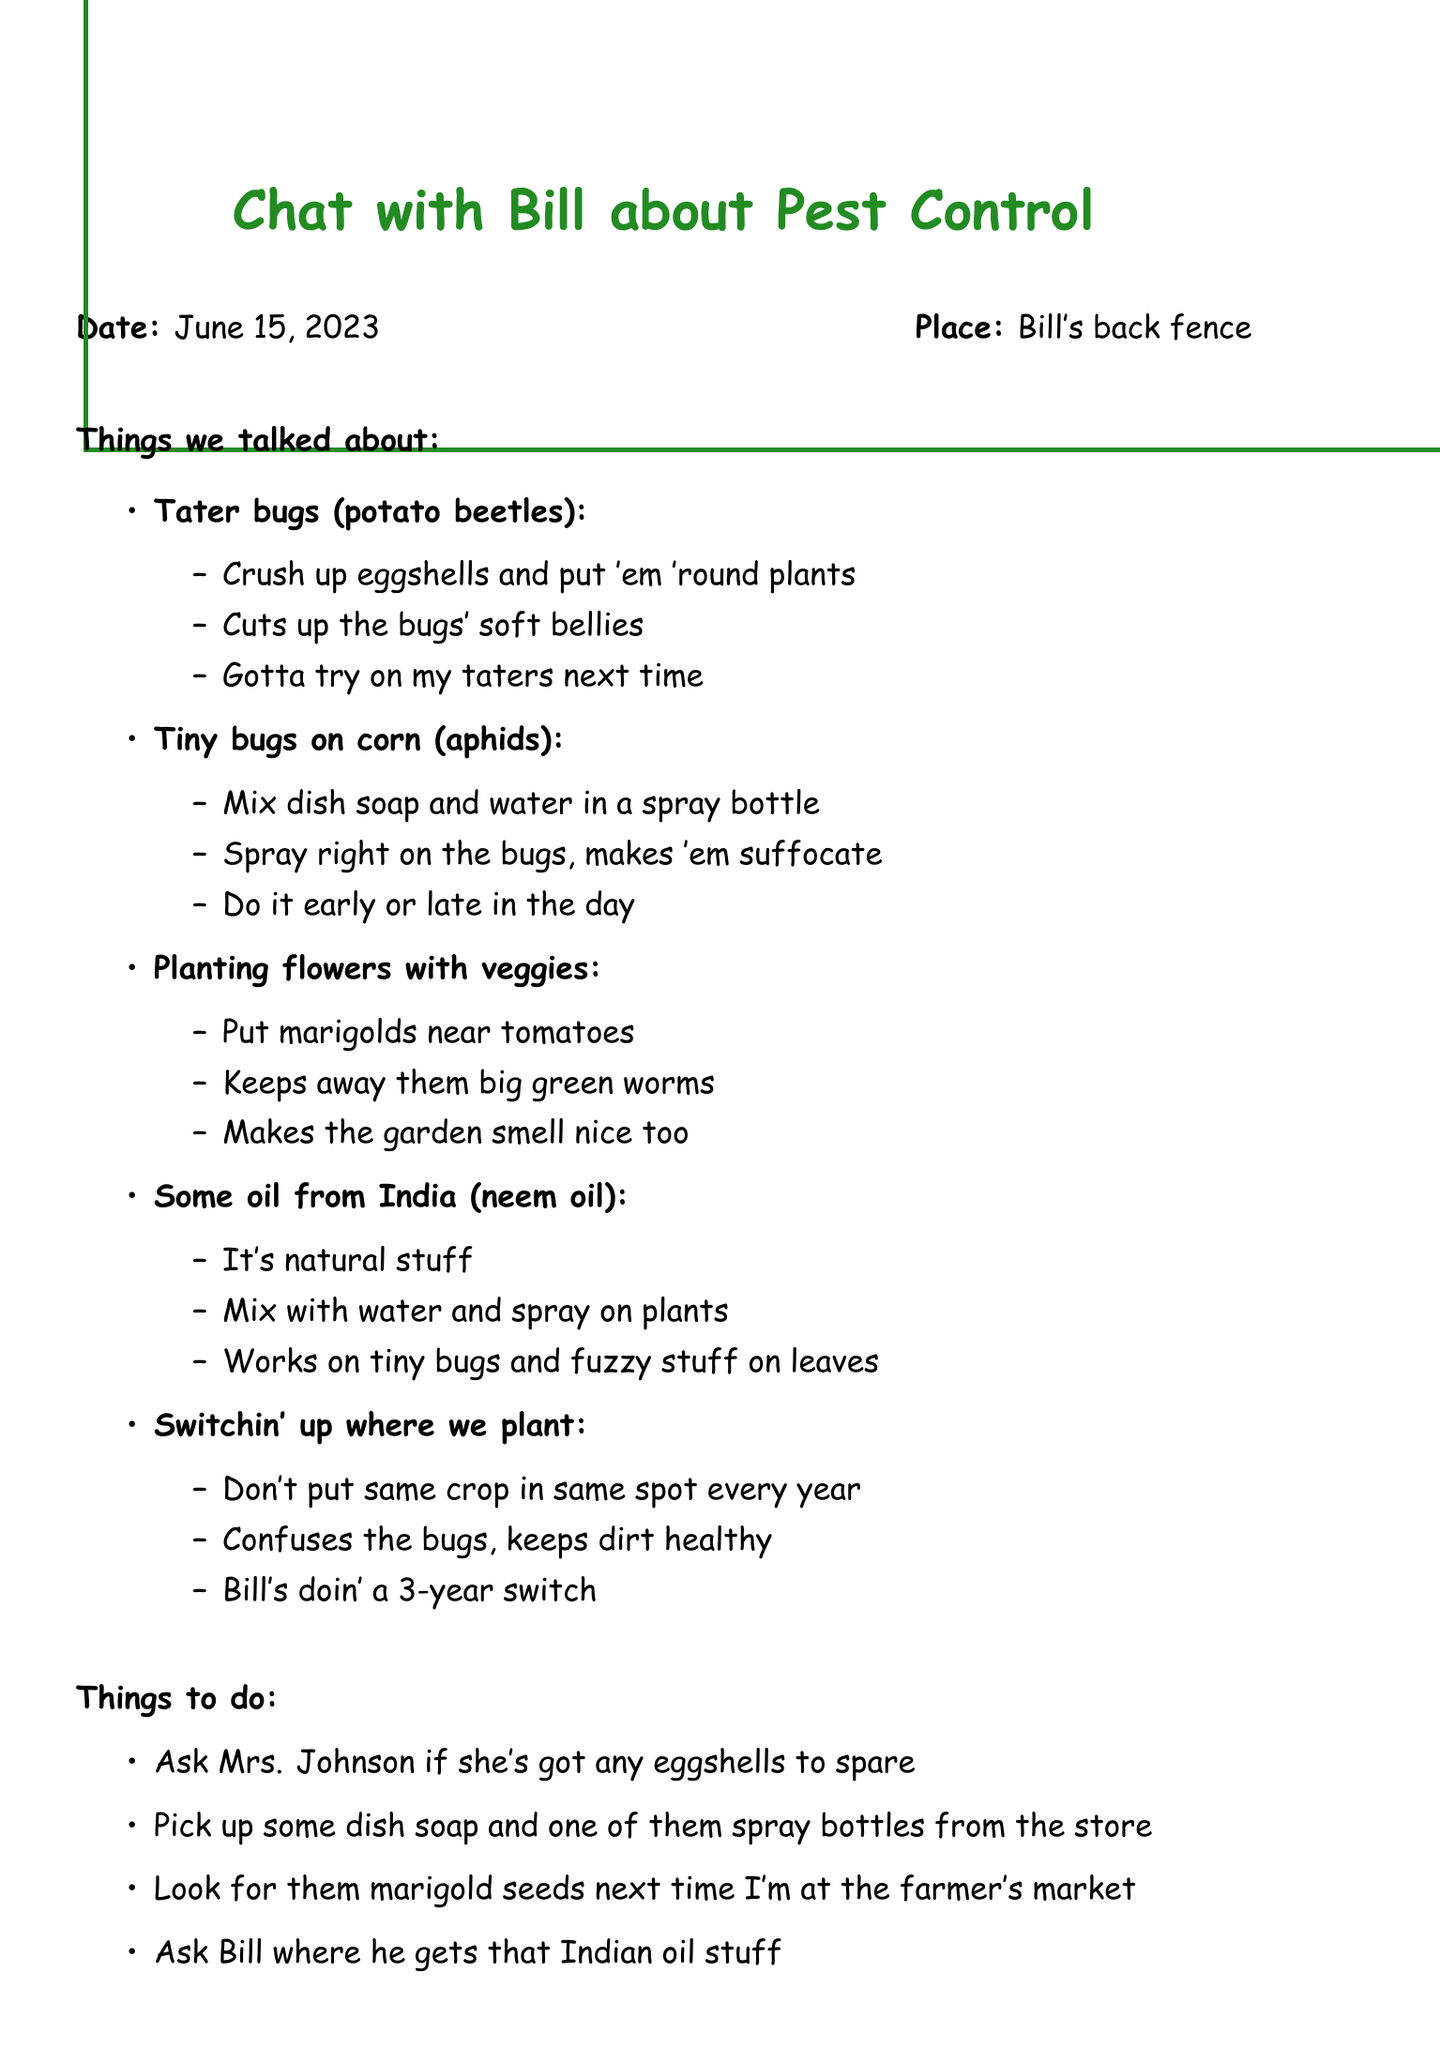What is the date of the conversation? The date of the conversation is stated at the beginning of the document.
Answer: June 15, 2023 Where did the conversation take place? The place of the conversation is mentioned alongside the date.
Answer: Bill's back fence What natural substance does Bill use to fight potato beetles? The document lists the method Bill uses for potato beetles in the notes section.
Answer: Crushed eggshells What is mixed with water to spray on aphids? The notes explain the method for dealing with aphids, including what to mix with water.
Answer: Dish soap How often does Bill rotate his crops? The document mentions the frequency of Bill's crop rotation in the last topic.
Answer: 3-year rotation Which flowers should be planted near tomatoes? This detail is found under the companion planting topic in the notes.
Answer: Marigolds What should be asked to Mrs. Johnson? The to-do list provides specific tasks, including a question for Mrs. Johnson.
Answer: For eggshells What type of oil is suggested for pest control? The document specifies the type of oil discussed for pest control.
Answer: Neem oil What is the benefit of planting marigolds? The reason for planting marigolds is mentioned in the companion planting notes.
Answer: Keeps away tomato hornworms 